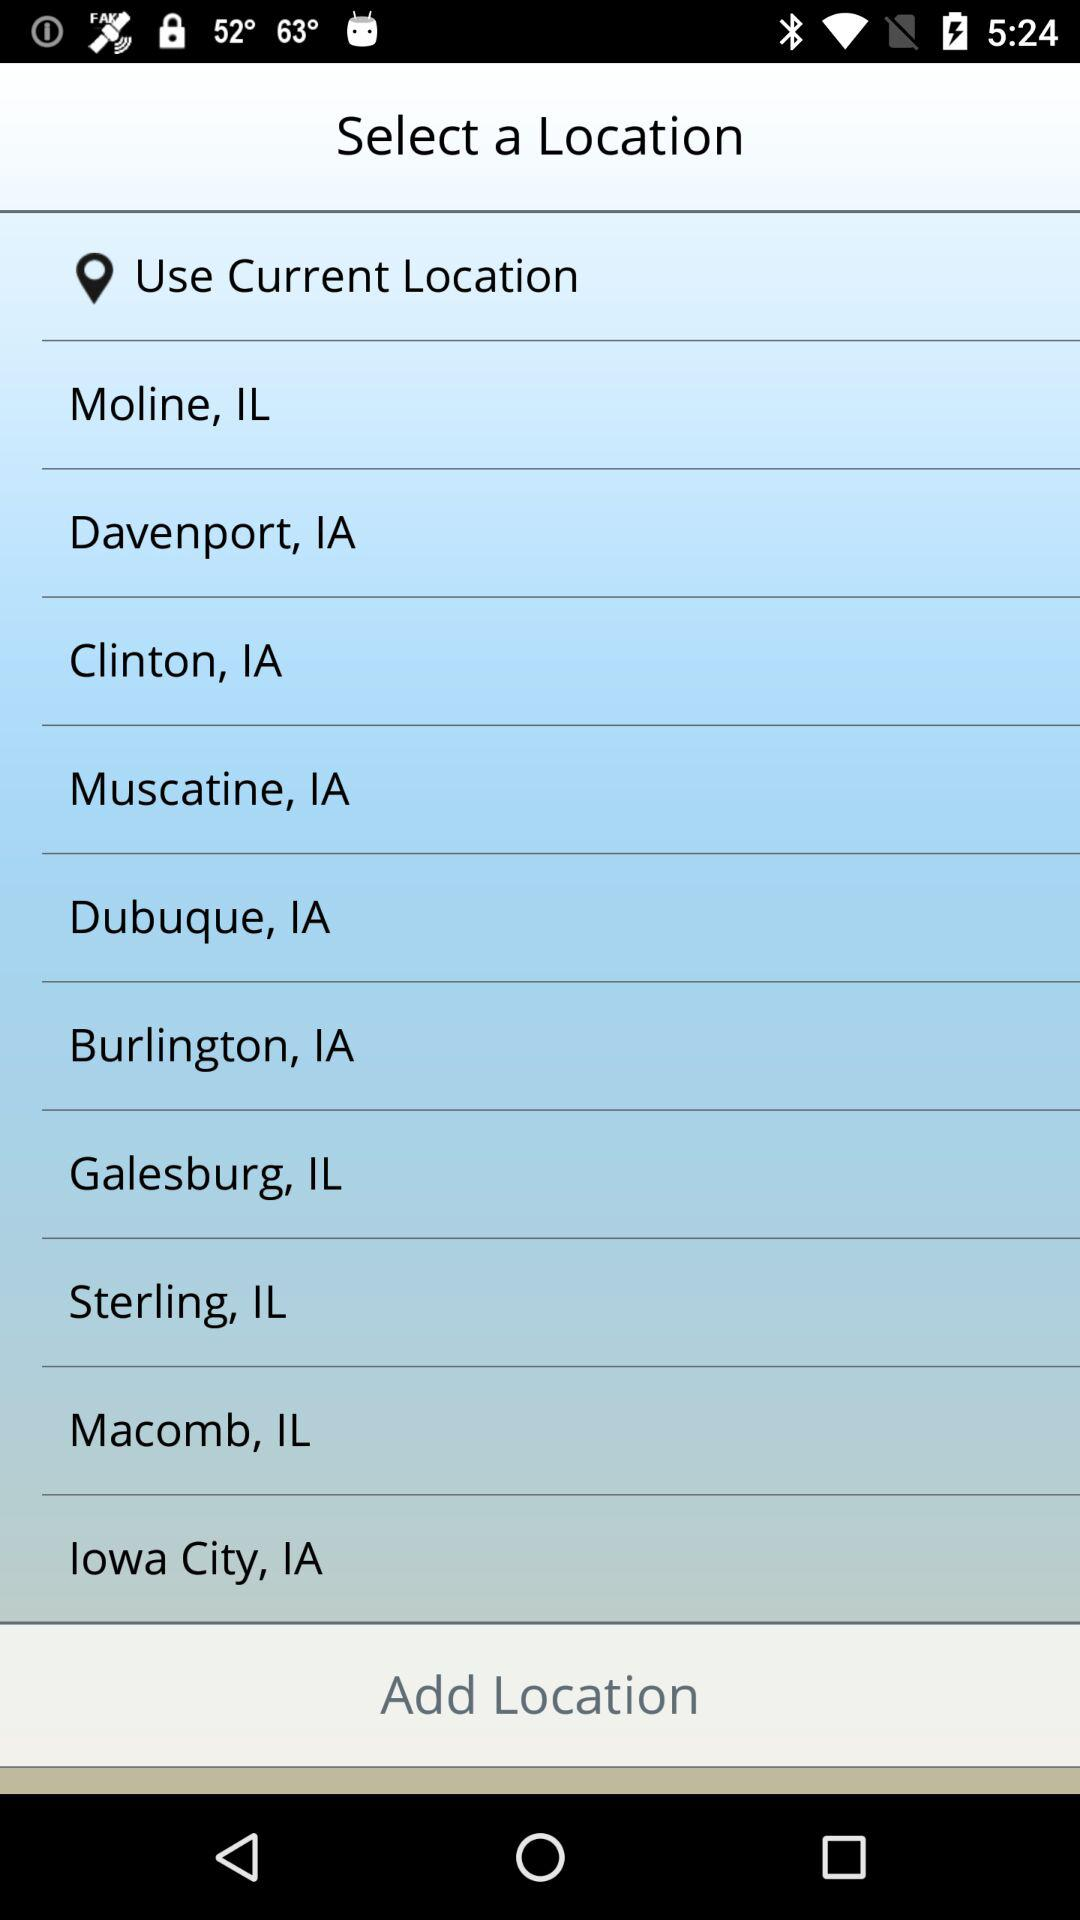What are the various locations to select? The various locations are Moline, IL; Davenport, IA; Clinton, IA; Muscatine, IA; Dubuque, IA; Burlington, IA; Galesburg, IL; Sterling, IL; Macomb, IL and Iowa City, IA. 